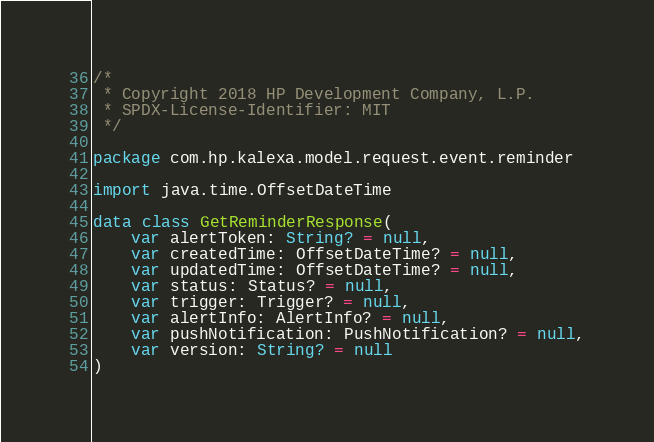<code> <loc_0><loc_0><loc_500><loc_500><_Kotlin_>/*
 * Copyright 2018 HP Development Company, L.P.
 * SPDX-License-Identifier: MIT
 */

package com.hp.kalexa.model.request.event.reminder

import java.time.OffsetDateTime

data class GetReminderResponse(
    var alertToken: String? = null,
    var createdTime: OffsetDateTime? = null,
    var updatedTime: OffsetDateTime? = null,
    var status: Status? = null,
    var trigger: Trigger? = null,
    var alertInfo: AlertInfo? = null,
    var pushNotification: PushNotification? = null,
    var version: String? = null
)
</code> 